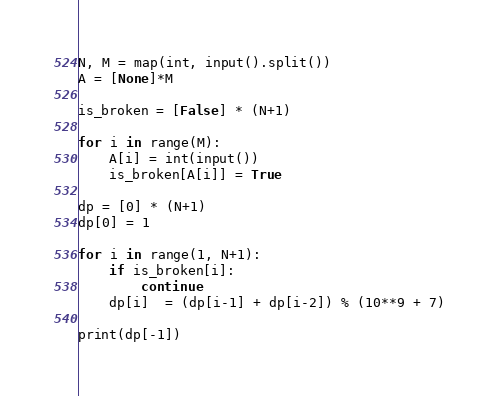<code> <loc_0><loc_0><loc_500><loc_500><_Python_>N, M = map(int, input().split())
A = [None]*M

is_broken = [False] * (N+1)

for i in range(M):
    A[i] = int(input())
    is_broken[A[i]] = True

dp = [0] * (N+1)
dp[0] = 1

for i in range(1, N+1):
    if is_broken[i]:
        continue
    dp[i]  = (dp[i-1] + dp[i-2]) % (10**9 + 7)

print(dp[-1])</code> 